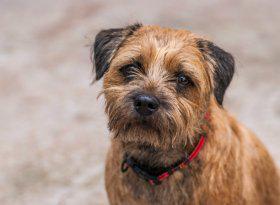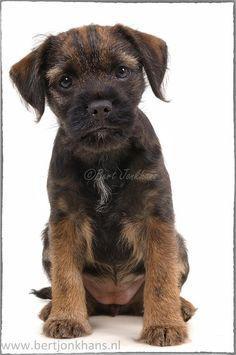The first image is the image on the left, the second image is the image on the right. Analyze the images presented: Is the assertion "The combined images contain three dogs, and one image contains a pair of similarly-posed reclining dogs." valid? Answer yes or no. No. The first image is the image on the left, the second image is the image on the right. Considering the images on both sides, is "In one image two dogs are laying down." valid? Answer yes or no. No. 